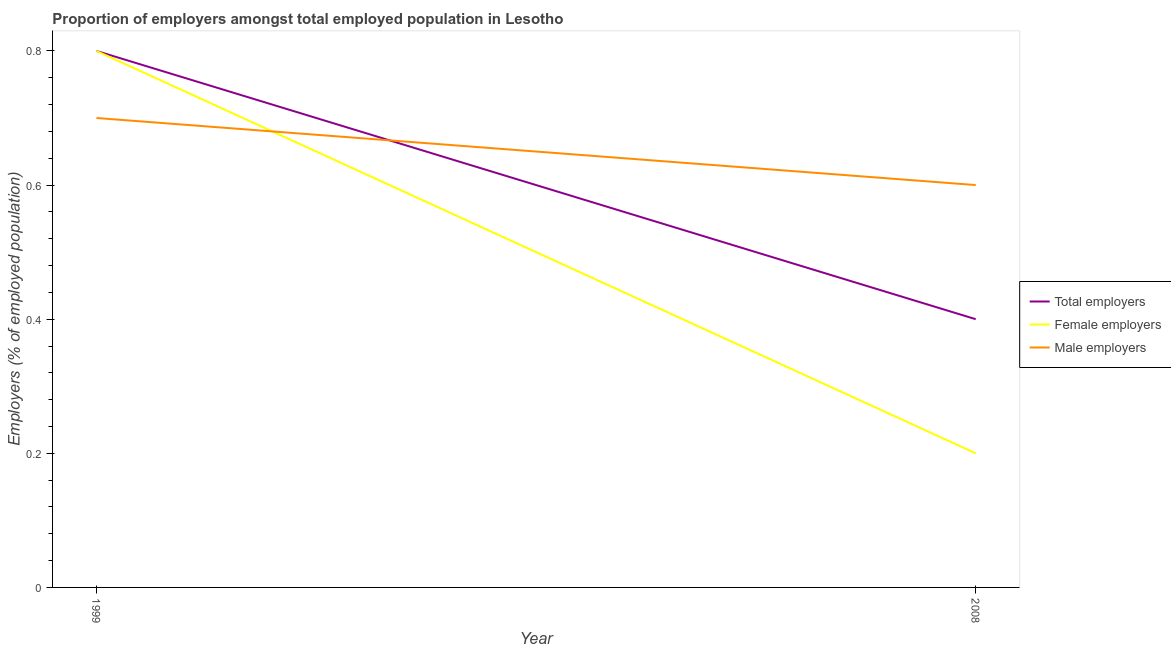Does the line corresponding to percentage of female employers intersect with the line corresponding to percentage of total employers?
Offer a very short reply. Yes. Is the number of lines equal to the number of legend labels?
Keep it short and to the point. Yes. What is the percentage of female employers in 1999?
Ensure brevity in your answer.  0.8. Across all years, what is the maximum percentage of male employers?
Offer a terse response. 0.7. Across all years, what is the minimum percentage of male employers?
Your response must be concise. 0.6. What is the total percentage of male employers in the graph?
Offer a very short reply. 1.3. What is the difference between the percentage of total employers in 1999 and that in 2008?
Provide a succinct answer. 0.4. What is the difference between the percentage of total employers in 2008 and the percentage of female employers in 1999?
Provide a succinct answer. -0.4. What is the average percentage of total employers per year?
Offer a terse response. 0.6. In the year 1999, what is the difference between the percentage of male employers and percentage of total employers?
Offer a terse response. -0.1. In how many years, is the percentage of male employers greater than 0.2 %?
Ensure brevity in your answer.  2. What is the ratio of the percentage of total employers in 1999 to that in 2008?
Provide a short and direct response. 2. In how many years, is the percentage of total employers greater than the average percentage of total employers taken over all years?
Offer a terse response. 1. Is it the case that in every year, the sum of the percentage of total employers and percentage of female employers is greater than the percentage of male employers?
Give a very brief answer. No. Does the percentage of total employers monotonically increase over the years?
Your answer should be very brief. No. How many years are there in the graph?
Make the answer very short. 2. Are the values on the major ticks of Y-axis written in scientific E-notation?
Your response must be concise. No. Does the graph contain grids?
Provide a succinct answer. No. How many legend labels are there?
Give a very brief answer. 3. How are the legend labels stacked?
Keep it short and to the point. Vertical. What is the title of the graph?
Ensure brevity in your answer.  Proportion of employers amongst total employed population in Lesotho. Does "Fuel" appear as one of the legend labels in the graph?
Make the answer very short. No. What is the label or title of the X-axis?
Provide a short and direct response. Year. What is the label or title of the Y-axis?
Give a very brief answer. Employers (% of employed population). What is the Employers (% of employed population) of Total employers in 1999?
Your answer should be very brief. 0.8. What is the Employers (% of employed population) of Female employers in 1999?
Provide a short and direct response. 0.8. What is the Employers (% of employed population) in Male employers in 1999?
Provide a short and direct response. 0.7. What is the Employers (% of employed population) in Total employers in 2008?
Keep it short and to the point. 0.4. What is the Employers (% of employed population) in Female employers in 2008?
Give a very brief answer. 0.2. What is the Employers (% of employed population) of Male employers in 2008?
Provide a short and direct response. 0.6. Across all years, what is the maximum Employers (% of employed population) in Total employers?
Make the answer very short. 0.8. Across all years, what is the maximum Employers (% of employed population) of Female employers?
Give a very brief answer. 0.8. Across all years, what is the maximum Employers (% of employed population) in Male employers?
Give a very brief answer. 0.7. Across all years, what is the minimum Employers (% of employed population) in Total employers?
Your response must be concise. 0.4. Across all years, what is the minimum Employers (% of employed population) of Female employers?
Your response must be concise. 0.2. Across all years, what is the minimum Employers (% of employed population) in Male employers?
Give a very brief answer. 0.6. What is the difference between the Employers (% of employed population) of Total employers in 1999 and that in 2008?
Offer a very short reply. 0.4. What is the difference between the Employers (% of employed population) in Total employers in 1999 and the Employers (% of employed population) in Male employers in 2008?
Your response must be concise. 0.2. What is the average Employers (% of employed population) of Total employers per year?
Offer a very short reply. 0.6. What is the average Employers (% of employed population) of Female employers per year?
Give a very brief answer. 0.5. What is the average Employers (% of employed population) of Male employers per year?
Your response must be concise. 0.65. In the year 1999, what is the difference between the Employers (% of employed population) in Total employers and Employers (% of employed population) in Male employers?
Offer a terse response. 0.1. In the year 1999, what is the difference between the Employers (% of employed population) in Female employers and Employers (% of employed population) in Male employers?
Provide a succinct answer. 0.1. In the year 2008, what is the difference between the Employers (% of employed population) in Total employers and Employers (% of employed population) in Male employers?
Your answer should be compact. -0.2. What is the ratio of the Employers (% of employed population) of Total employers in 1999 to that in 2008?
Make the answer very short. 2. What is the ratio of the Employers (% of employed population) in Female employers in 1999 to that in 2008?
Offer a very short reply. 4. What is the ratio of the Employers (% of employed population) in Male employers in 1999 to that in 2008?
Provide a short and direct response. 1.17. What is the difference between the highest and the second highest Employers (% of employed population) in Female employers?
Your answer should be compact. 0.6. What is the difference between the highest and the second highest Employers (% of employed population) in Male employers?
Offer a terse response. 0.1. What is the difference between the highest and the lowest Employers (% of employed population) of Total employers?
Provide a short and direct response. 0.4. 